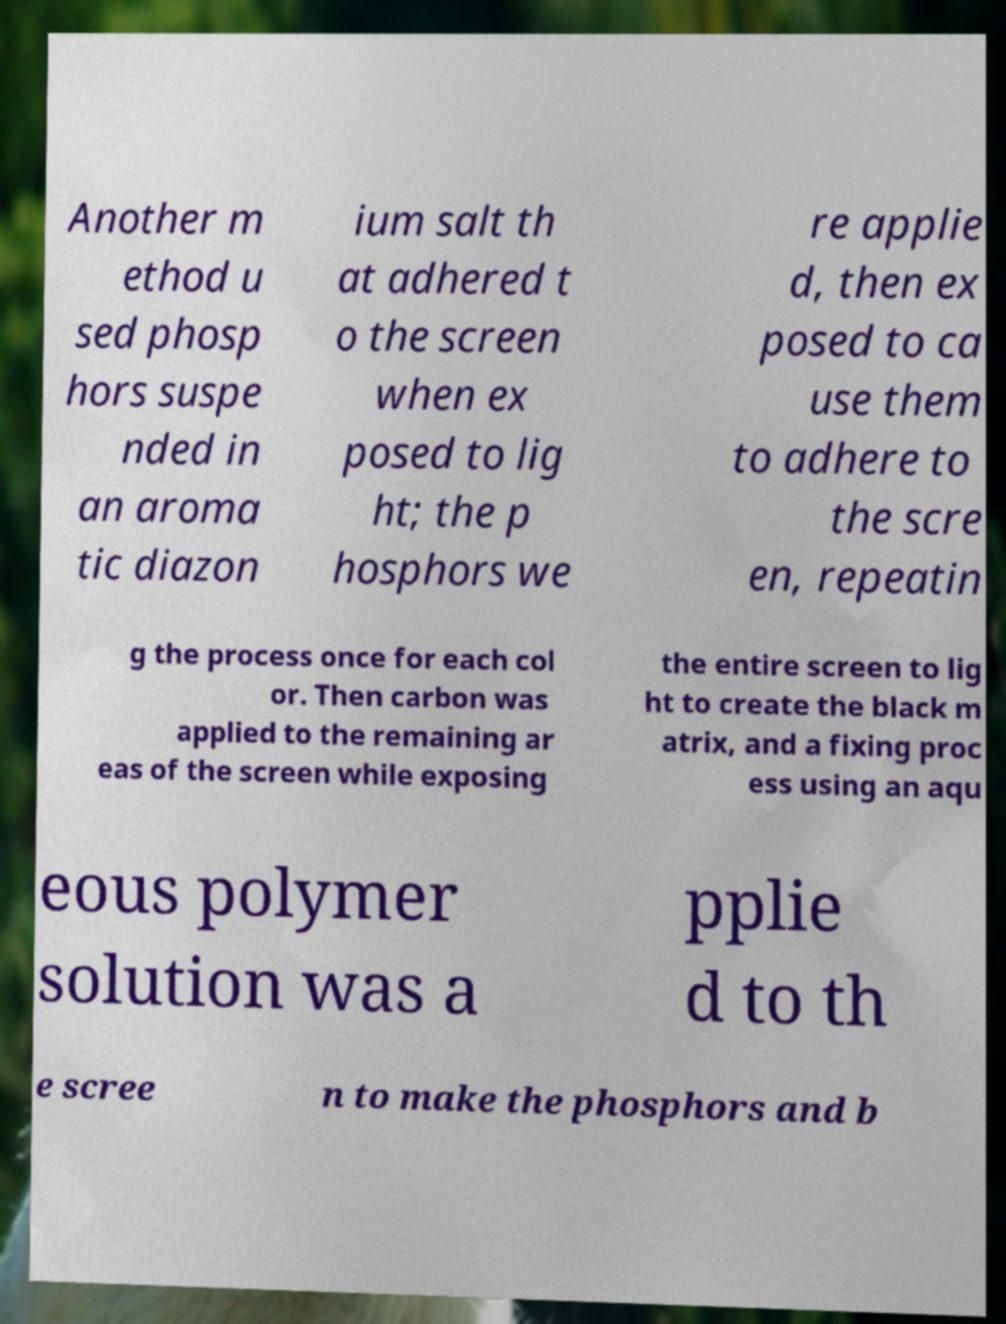Please identify and transcribe the text found in this image. Another m ethod u sed phosp hors suspe nded in an aroma tic diazon ium salt th at adhered t o the screen when ex posed to lig ht; the p hosphors we re applie d, then ex posed to ca use them to adhere to the scre en, repeatin g the process once for each col or. Then carbon was applied to the remaining ar eas of the screen while exposing the entire screen to lig ht to create the black m atrix, and a fixing proc ess using an aqu eous polymer solution was a pplie d to th e scree n to make the phosphors and b 